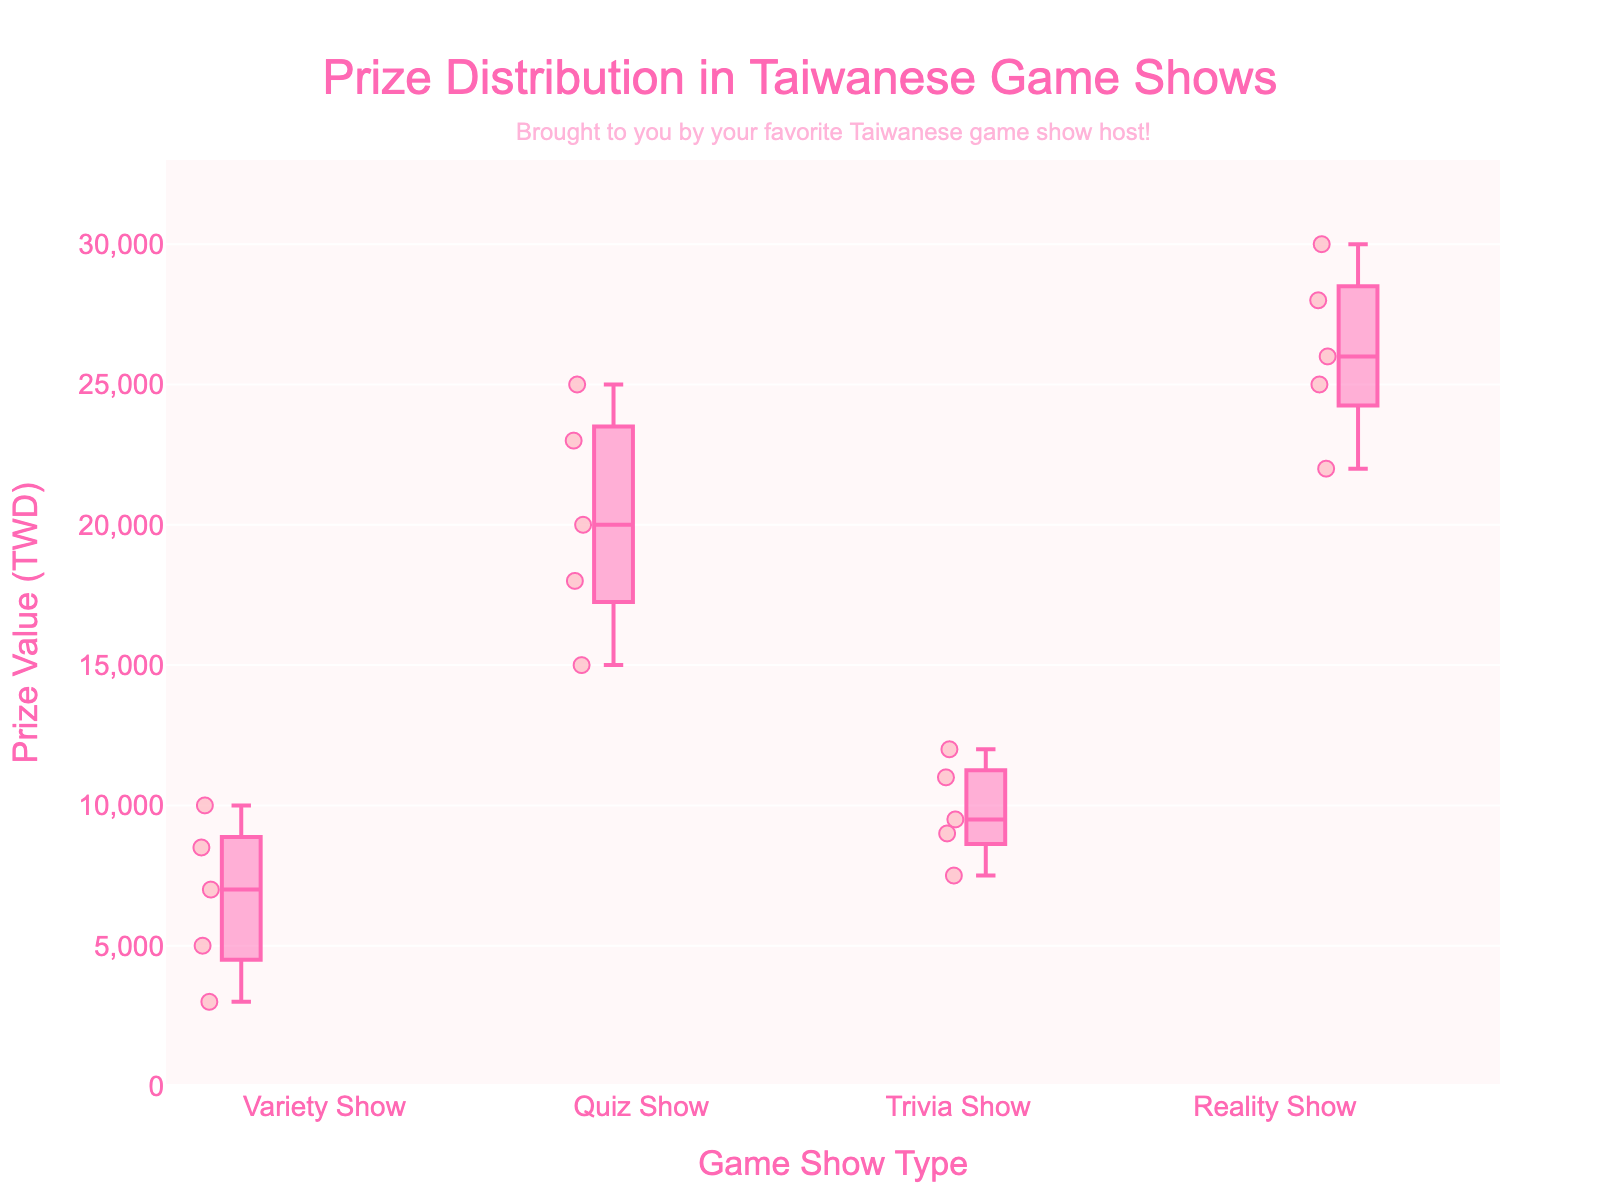What is the title of the plot? The title of the plot is displayed at the top center of the figure and it reads "Prize Distribution in Taiwanese Game Shows".
Answer: Prize Distribution in Taiwanese Game Shows Which game show type has the highest median prize value? In a box plot, the median is represented by the line inside the box. Comparing the medians of all game show types, the Reality Show has the highest median prize value.
Answer: Reality Show How many prize values are plotted for the Quiz Show category? A box plot with 'all points' option displays individual data points. Counting the individual points (dots) in the Quiz Show category, there are 5 prize values plotted.
Answer: 5 What is the interquartile range (IQR) for the Variety Show? The IQR is the difference between the third quartile (top of the box) and the first quartile (bottom of the box). For the Variety Show, the box extends approximately from 5000 TWD to 8500 TWD, making the IQR 8500 - 5000 = 3500 TWD.
Answer: 3500 TWD Which game show type has the smallest range of prize values? The range is the difference between the maximum and minimum values. The Variety Show has the smallest range because its whiskers (the lines extending from the box) stretch from about 3000 to 10000 TWD, resulting in a range of 10000 - 3000 = 7000 TWD. No other category has a smaller range.
Answer: Variety Show What's the lowest prize value in the Reality Show category? The lowest prize value in the Reality Show category is marked by the bottom whisker or the lowest point. This value is approximately 22000 TWD.
Answer: 22000 TWD Which game show type has the most spread-out prize values? To determine the most spread-out values, we look at the length of the whiskers. The Reality Show category has the whiskers stretching from about 22000 to 30000 TWD, indicating it has the most spread-out prize values.
Answer: Reality Show Compare the median prize values of Trivia Show and Quiz Show. Which is higher? The median is indicated by the line in the middle of each box. By comparing these lines, the Quiz Show has a higher median prize value compared to the Trivia Show.
Answer: Quiz Show Which game show type has prize values that vary between 7500 TWD and 12000 TWD? Looking at the data points and the box plot, the Trivia Show has prize values falling between 7500 TWD and 12000 TWD.
Answer: Trivia Show 